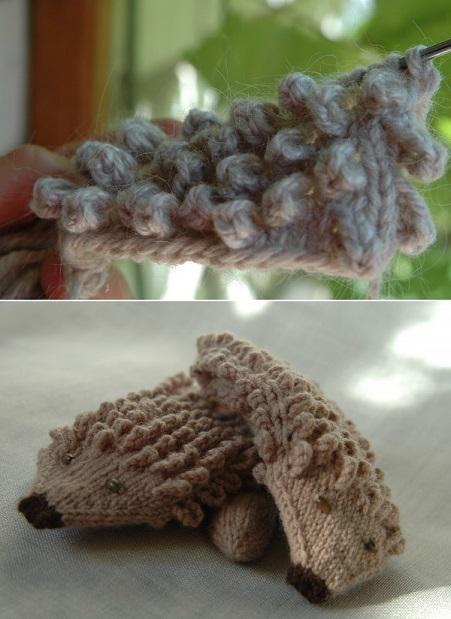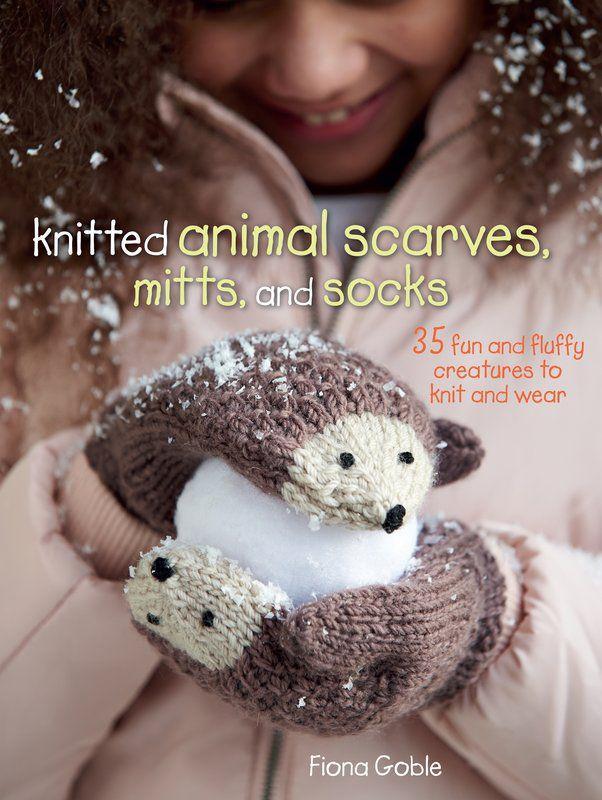The first image is the image on the left, the second image is the image on the right. Given the left and right images, does the statement "human hands are visible" hold true? Answer yes or no. No. 